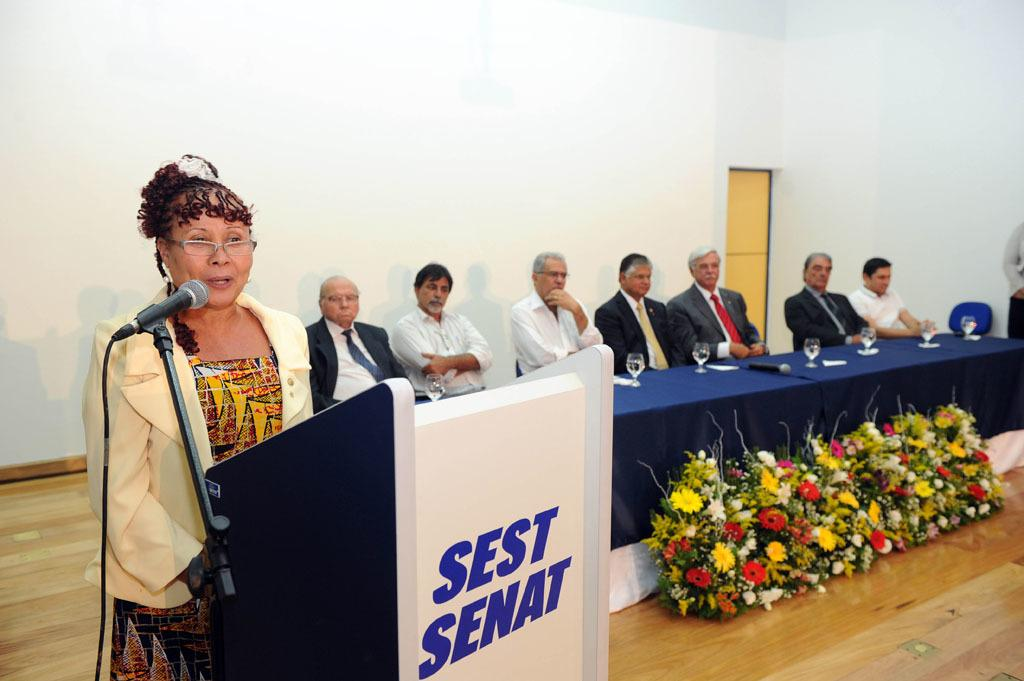<image>
Give a short and clear explanation of the subsequent image. A woman is speaking at a podium that says "SEST SENAT" in front of a panel of men. 